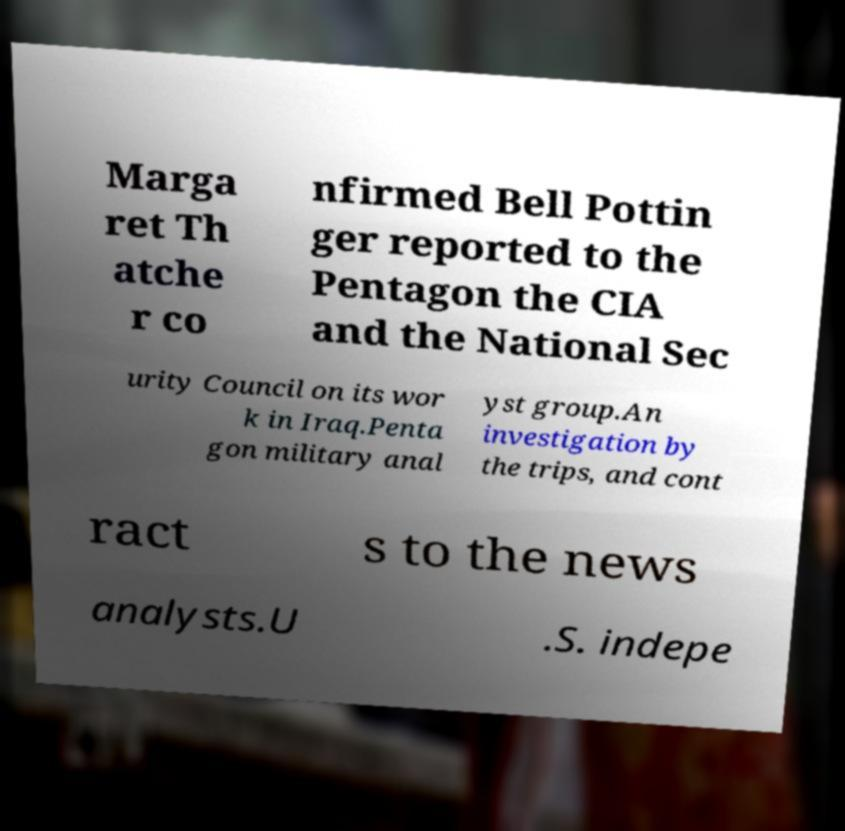What messages or text are displayed in this image? I need them in a readable, typed format. Marga ret Th atche r co nfirmed Bell Pottin ger reported to the Pentagon the CIA and the National Sec urity Council on its wor k in Iraq.Penta gon military anal yst group.An investigation by the trips, and cont ract s to the news analysts.U .S. indepe 